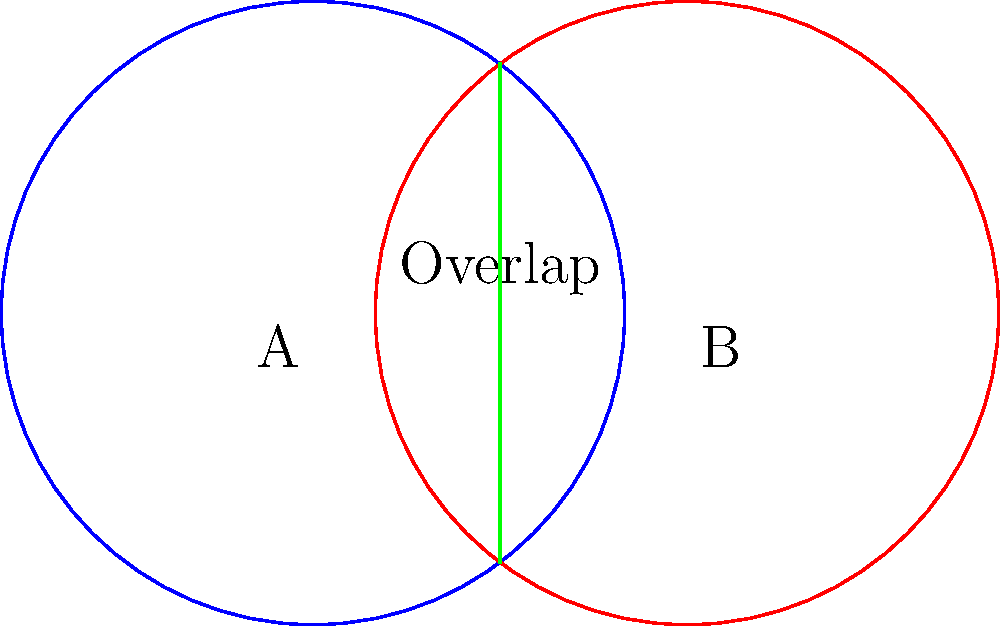As a tech support representative managing server reliability, you're tasked with optimizing network coverage for a blog's infrastructure. Two wireless access points, A and B, are placed 3 units apart, each with a coverage radius of 2.5 units. Calculate the area of the overlapping coverage zone to determine the redundancy in the network setup. Use $\pi = 3.14$ for your calculations. To solve this problem, we'll follow these steps:

1) First, we need to find the distance between the centers of the circles. This is given as 3 units.

2) Next, we'll calculate the area of the lens-shaped overlap using the formula:

   $$A = 2r^2 \arccos(\frac{d}{2r}) - d\sqrt{r^2 - (\frac{d}{2})^2}$$

   Where:
   $A$ is the area of overlap
   $r$ is the radius of each circle (2.5 units)
   $d$ is the distance between the centers (3 units)

3) Let's substitute these values:

   $$A = 2(2.5)^2 \arccos(\frac{3}{2(2.5)}) - 3\sqrt{(2.5)^2 - (\frac{3}{2})^2}$$

4) Simplify:
   $$A = 12.5 \arccos(0.6) - 3\sqrt{6.25 - 2.25}$$
   $$A = 12.5 \arccos(0.6) - 3\sqrt{4}$$
   $$A = 12.5 \arccos(0.6) - 6$$

5) Calculate $\arccos(0.6)$:
   $\arccos(0.6) \approx 0.9273$ radians

6) Substitute this value:
   $$A = 12.5(0.9273) - 6$$
   $$A = 11.59125 - 6$$
   $$A = 5.59125$$

7) Round to two decimal places:
   $$A \approx 5.59$$ square units

This overlap represents the area where there's redundant coverage, which can be beneficial for ensuring continuous connectivity but might also indicate over-provisioning of resources.
Answer: 5.59 square units 